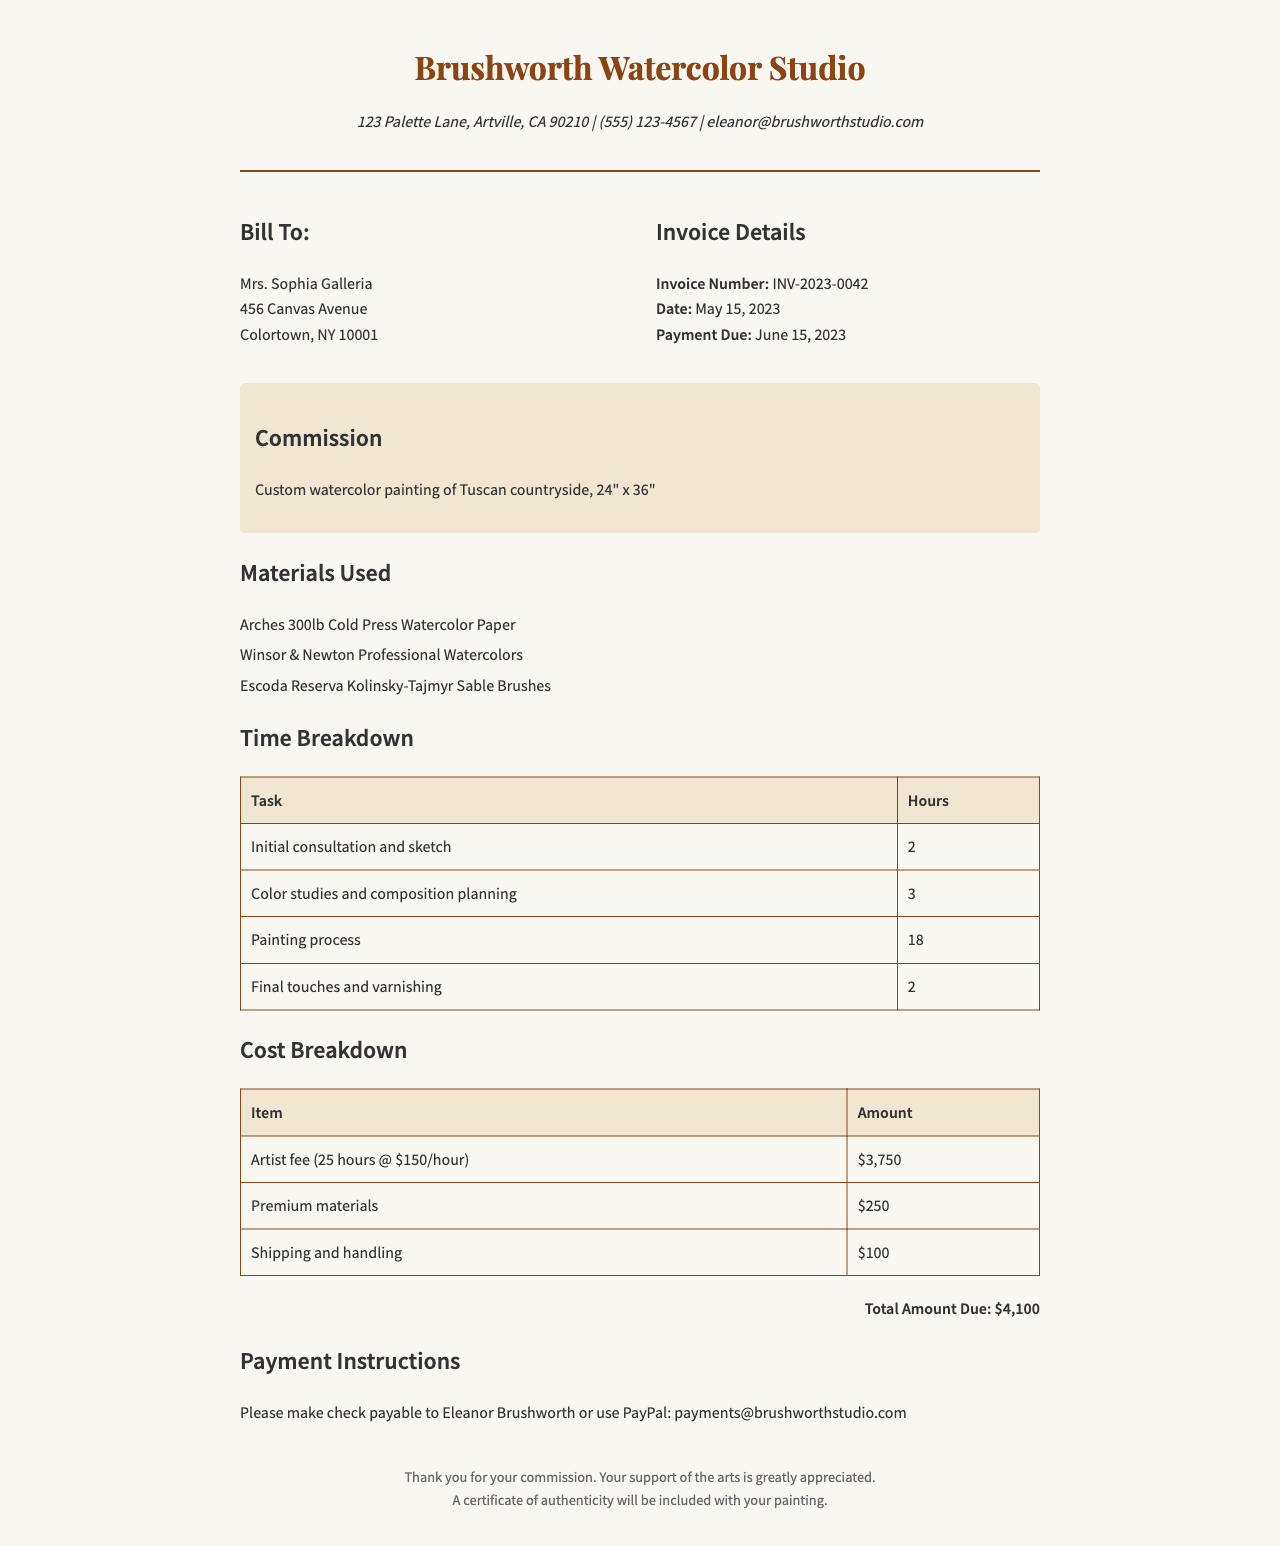What is the invoice number? The invoice number is found in the document under "Invoice Details."
Answer: INV-2023-0042 Who is the client? The client is listed under the "Bill To" section with their name and address.
Answer: Mrs. Sophia Galleria What is the total amount due? The total amount due is indicated at the bottom of the document.
Answer: $4,100 How many hours were spent on the painting process? The document provides a detailed time breakdown, showing hours spent on each task.
Answer: 18 What material is used for the watercolor paper? The document includes a list of materials used for the commission.
Answer: Arches 300lb Cold Press Watercolor Paper What is the artist fee per hour? The document details the cost breakdown for the artist's fees.
Answer: $150/hour What is the due date for payment? The due date is mentioned in the "Invoice Details" section of the document.
Answer: June 15, 2023 How many tasks are listed in the time breakdown? The time breakdown is presented in a table format listing individual tasks.
Answer: 4 What type of brushes were used? The materials section mentions the type of brushes that were utilized for the painting.
Answer: Escoda Reserva Kolinsky-Tajmyr Sable Brushes 